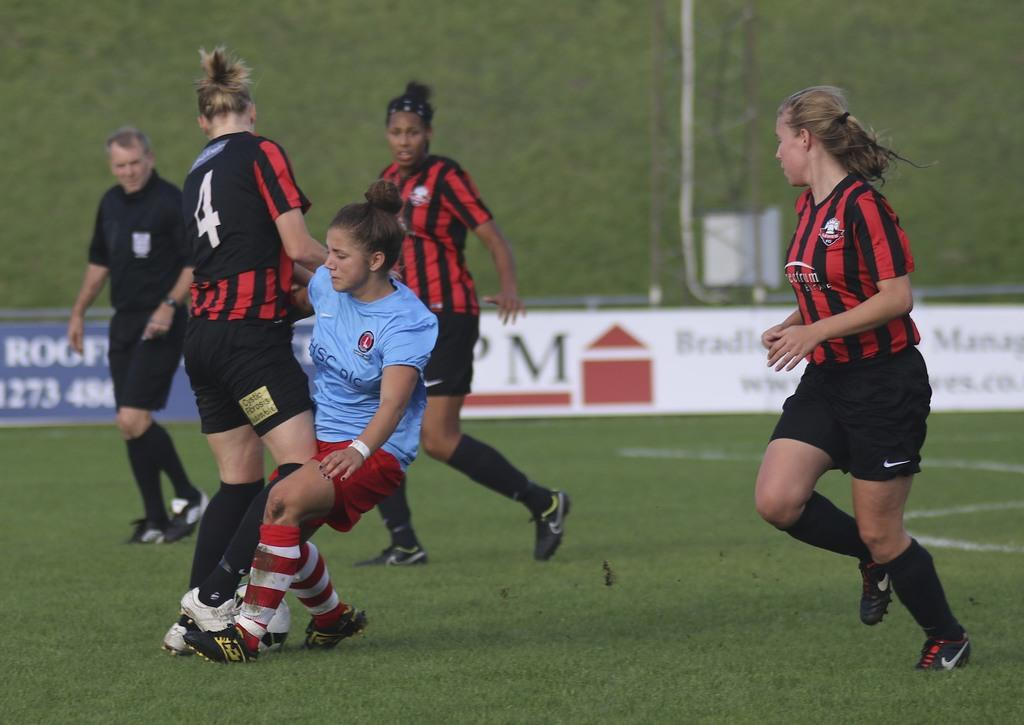How many people are present in the image? There are five people in the image. What are the people doing in the image? The people are playing a game. What type of surface can be seen beneath the people? There is grass visible in the image. What type of shoes are the maid wearing in the image? There is no maid present in the image, and therefore no shoes to describe. 